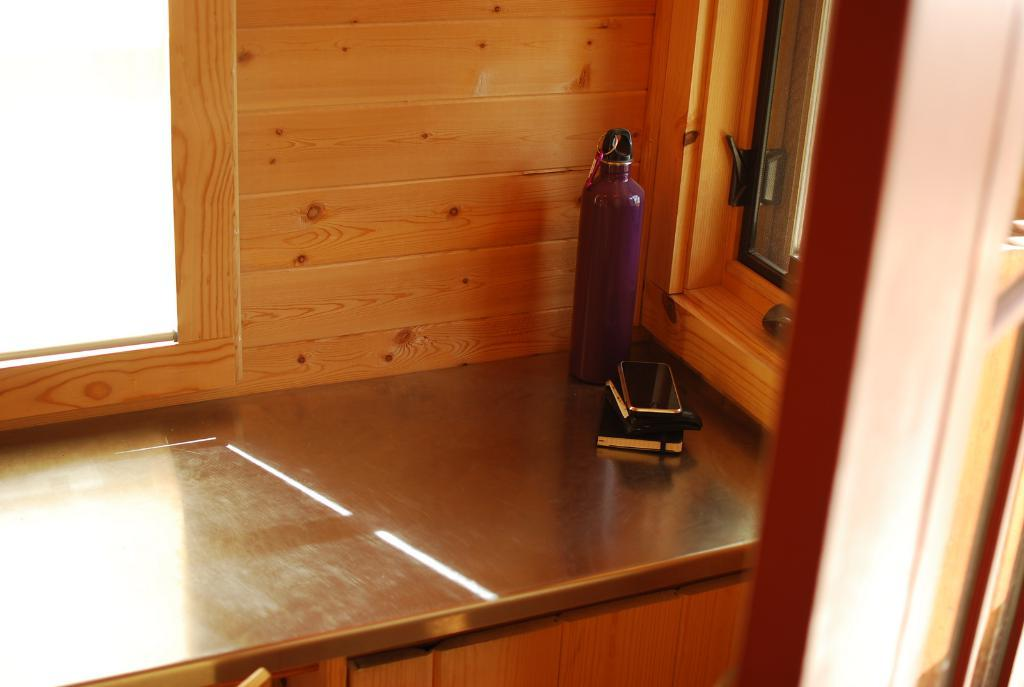What object can be seen hanging in the image? There is a mobile in the image. What type of personal item is visible in the image? There is a diary in the image. What is sitting on the surface in the image? There is a bottle on the surface in the image. What architectural feature is on the right side of the image? There is a window on the right side of the image. What other feature is on the right side of the image? There is a door on the right side of the image. What type of ink is used in the diary in the image? There is no indication of the type of ink used in the diary in the image, as the diary is not open or being written in. 